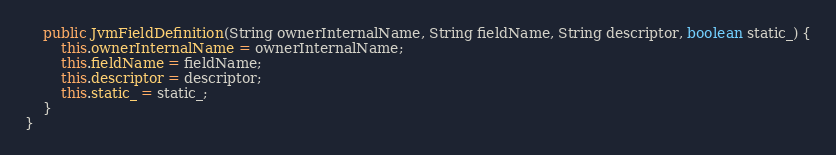<code> <loc_0><loc_0><loc_500><loc_500><_Java_>
    public JvmFieldDefinition(String ownerInternalName, String fieldName, String descriptor, boolean static_) {
        this.ownerInternalName = ownerInternalName;
        this.fieldName = fieldName;
        this.descriptor = descriptor;
        this.static_ = static_;
    }
}
</code> 